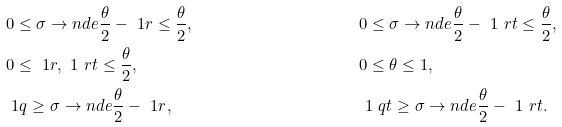<formula> <loc_0><loc_0><loc_500><loc_500>& 0 \leq \sigma \to n d e { \frac { \theta } { 2 } - \ 1 r } \leq \frac { \theta } { 2 } , & & 0 \leq \sigma \to n d e { \frac { \theta } { 2 } - \ 1 \ r t } \leq \frac { \theta } { 2 } , \\ & 0 \leq \ 1 r , \ 1 \ r t \leq \frac { \theta } { 2 } , & & 0 \leq \theta \leq 1 , \\ & \ 1 q \geq \sigma \to n d e { \frac { \theta } { 2 } - \ 1 r } , & & \ 1 \ q t \geq \sigma \to n d e { \frac { \theta } { 2 } - \ 1 \ r t } .</formula> 